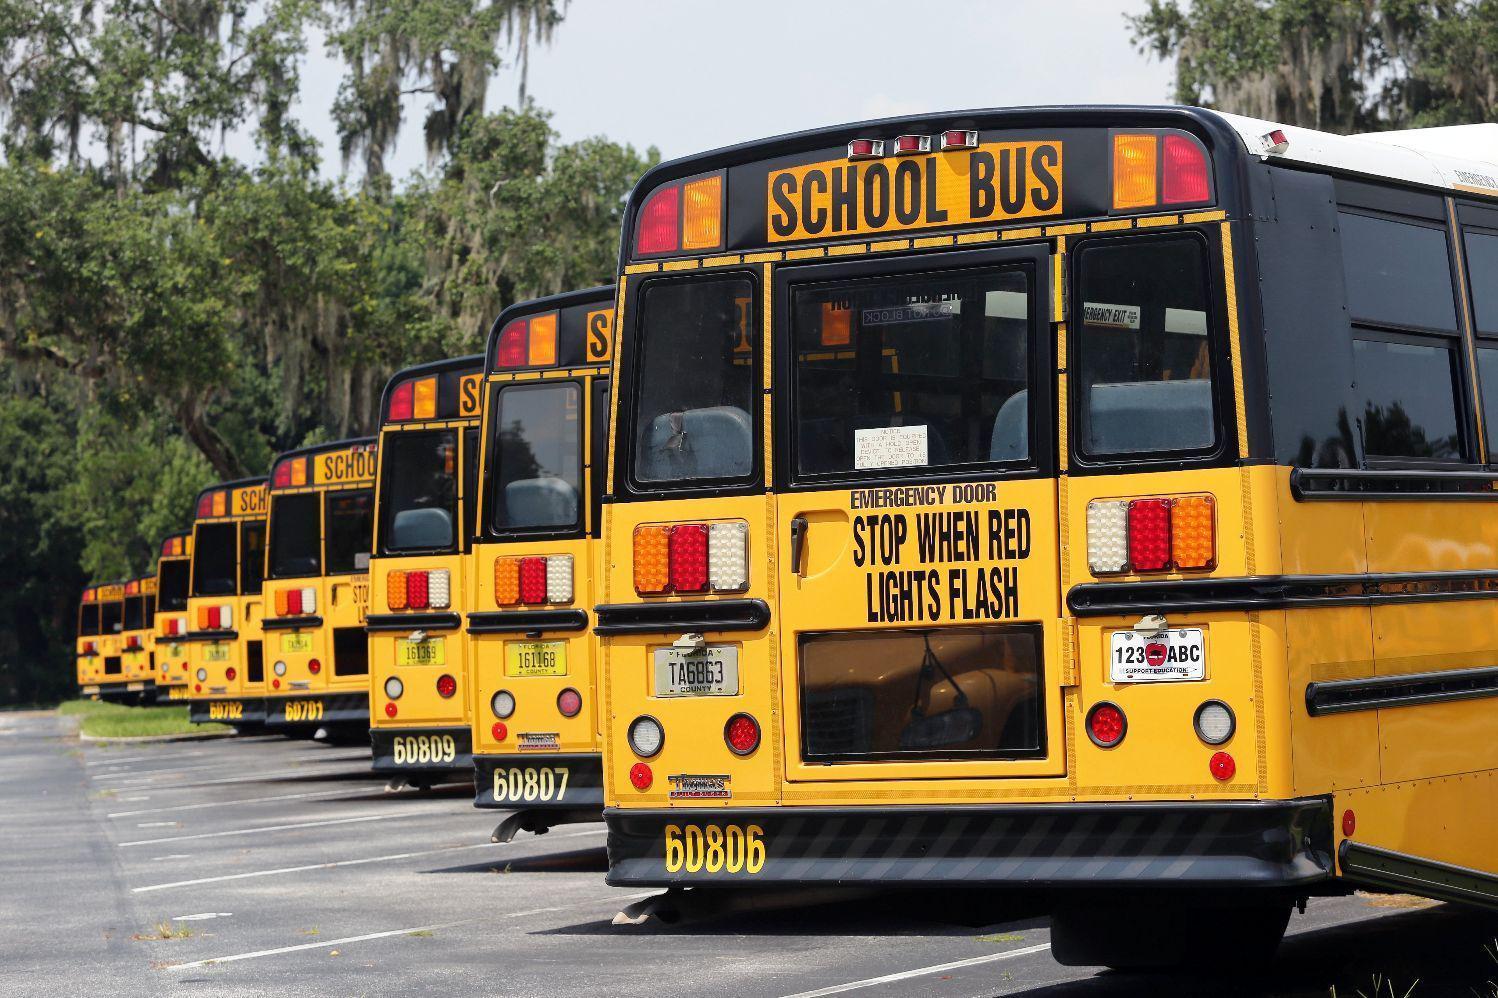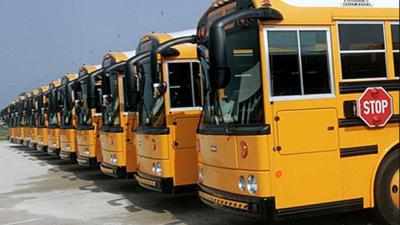The first image is the image on the left, the second image is the image on the right. Considering the images on both sides, is "At least 3 school buses are parked side by side in one of the pictures." valid? Answer yes or no. Yes. The first image is the image on the left, the second image is the image on the right. Assess this claim about the two images: "Yellow school buses are lined up side by side and facing forward in one of the images.". Correct or not? Answer yes or no. Yes. 